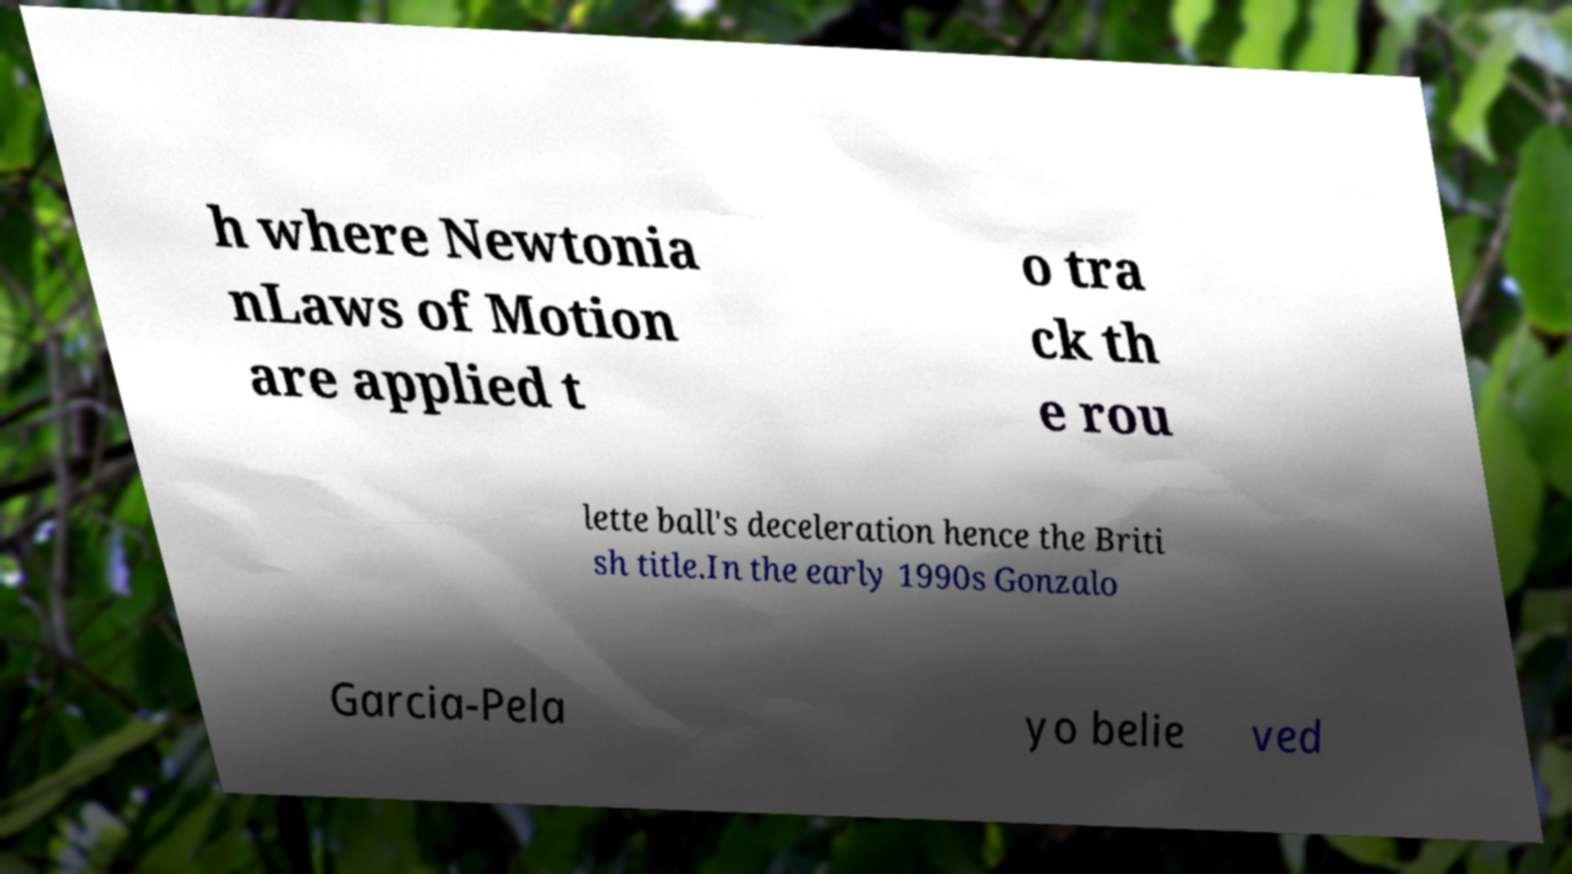Could you extract and type out the text from this image? h where Newtonia nLaws of Motion are applied t o tra ck th e rou lette ball's deceleration hence the Briti sh title.In the early 1990s Gonzalo Garcia-Pela yo belie ved 